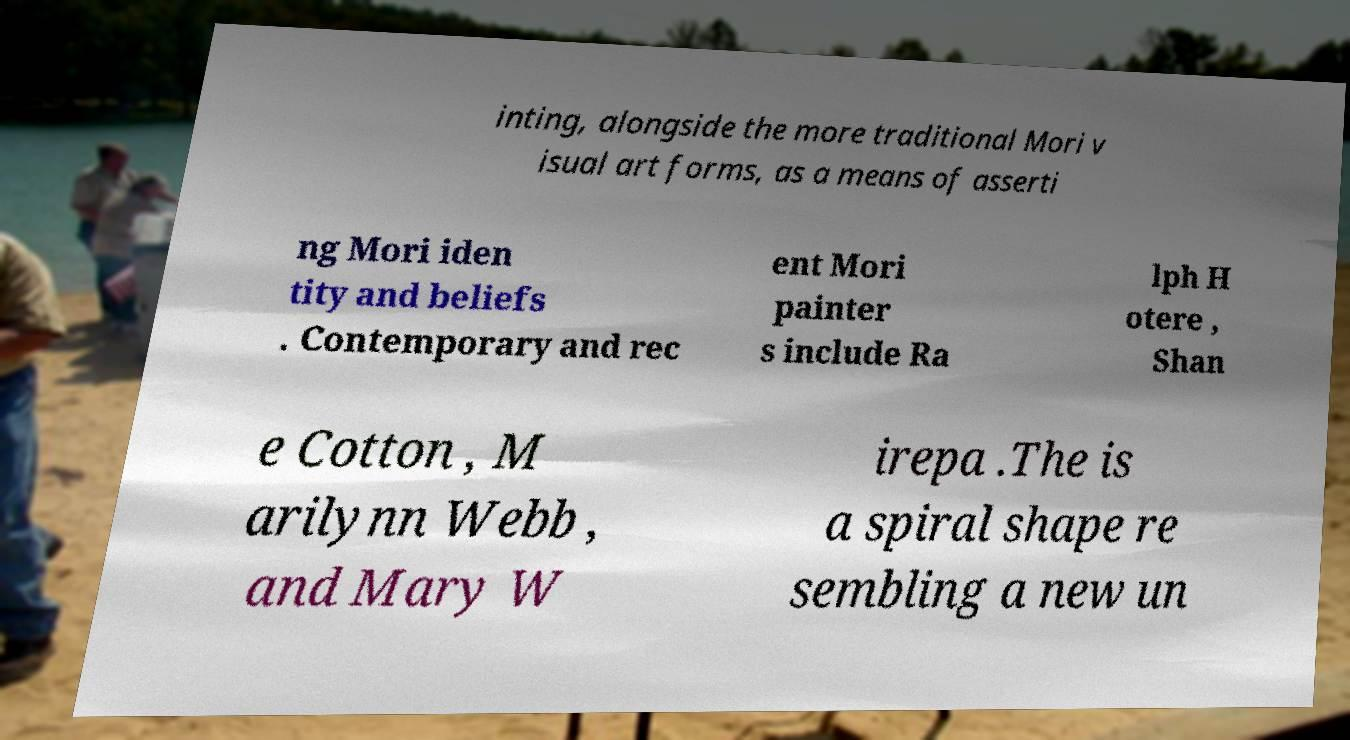There's text embedded in this image that I need extracted. Can you transcribe it verbatim? inting, alongside the more traditional Mori v isual art forms, as a means of asserti ng Mori iden tity and beliefs . Contemporary and rec ent Mori painter s include Ra lph H otere , Shan e Cotton , M arilynn Webb , and Mary W irepa .The is a spiral shape re sembling a new un 